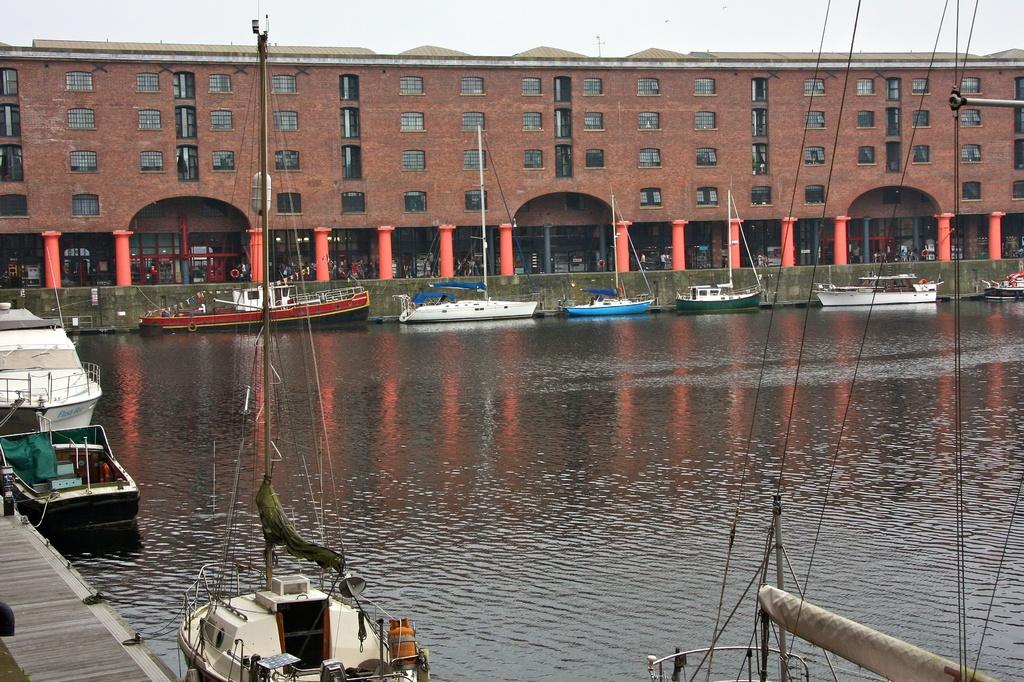How many people are in the image? There are people in the image, but the exact number is not specified. What type of structure is present in the image? There is a building with windows and pillars in the image. What is the purpose of the fencing in the image? The purpose of the fencing in the image is not specified. What are the boats with poles used for in the image? The boats with poles are likely used for navigating the water in the image. What type of surface is visible in the image? There is a wooden path in the image. What is visible in the sky in the image? The sky is visible in the image, but the weather or time of day is not specified. What type of quill is being used by the father in the image? There is no father or quill present in the image. What type of business is being conducted in the image? The image does not depict any business activities or transactions. 